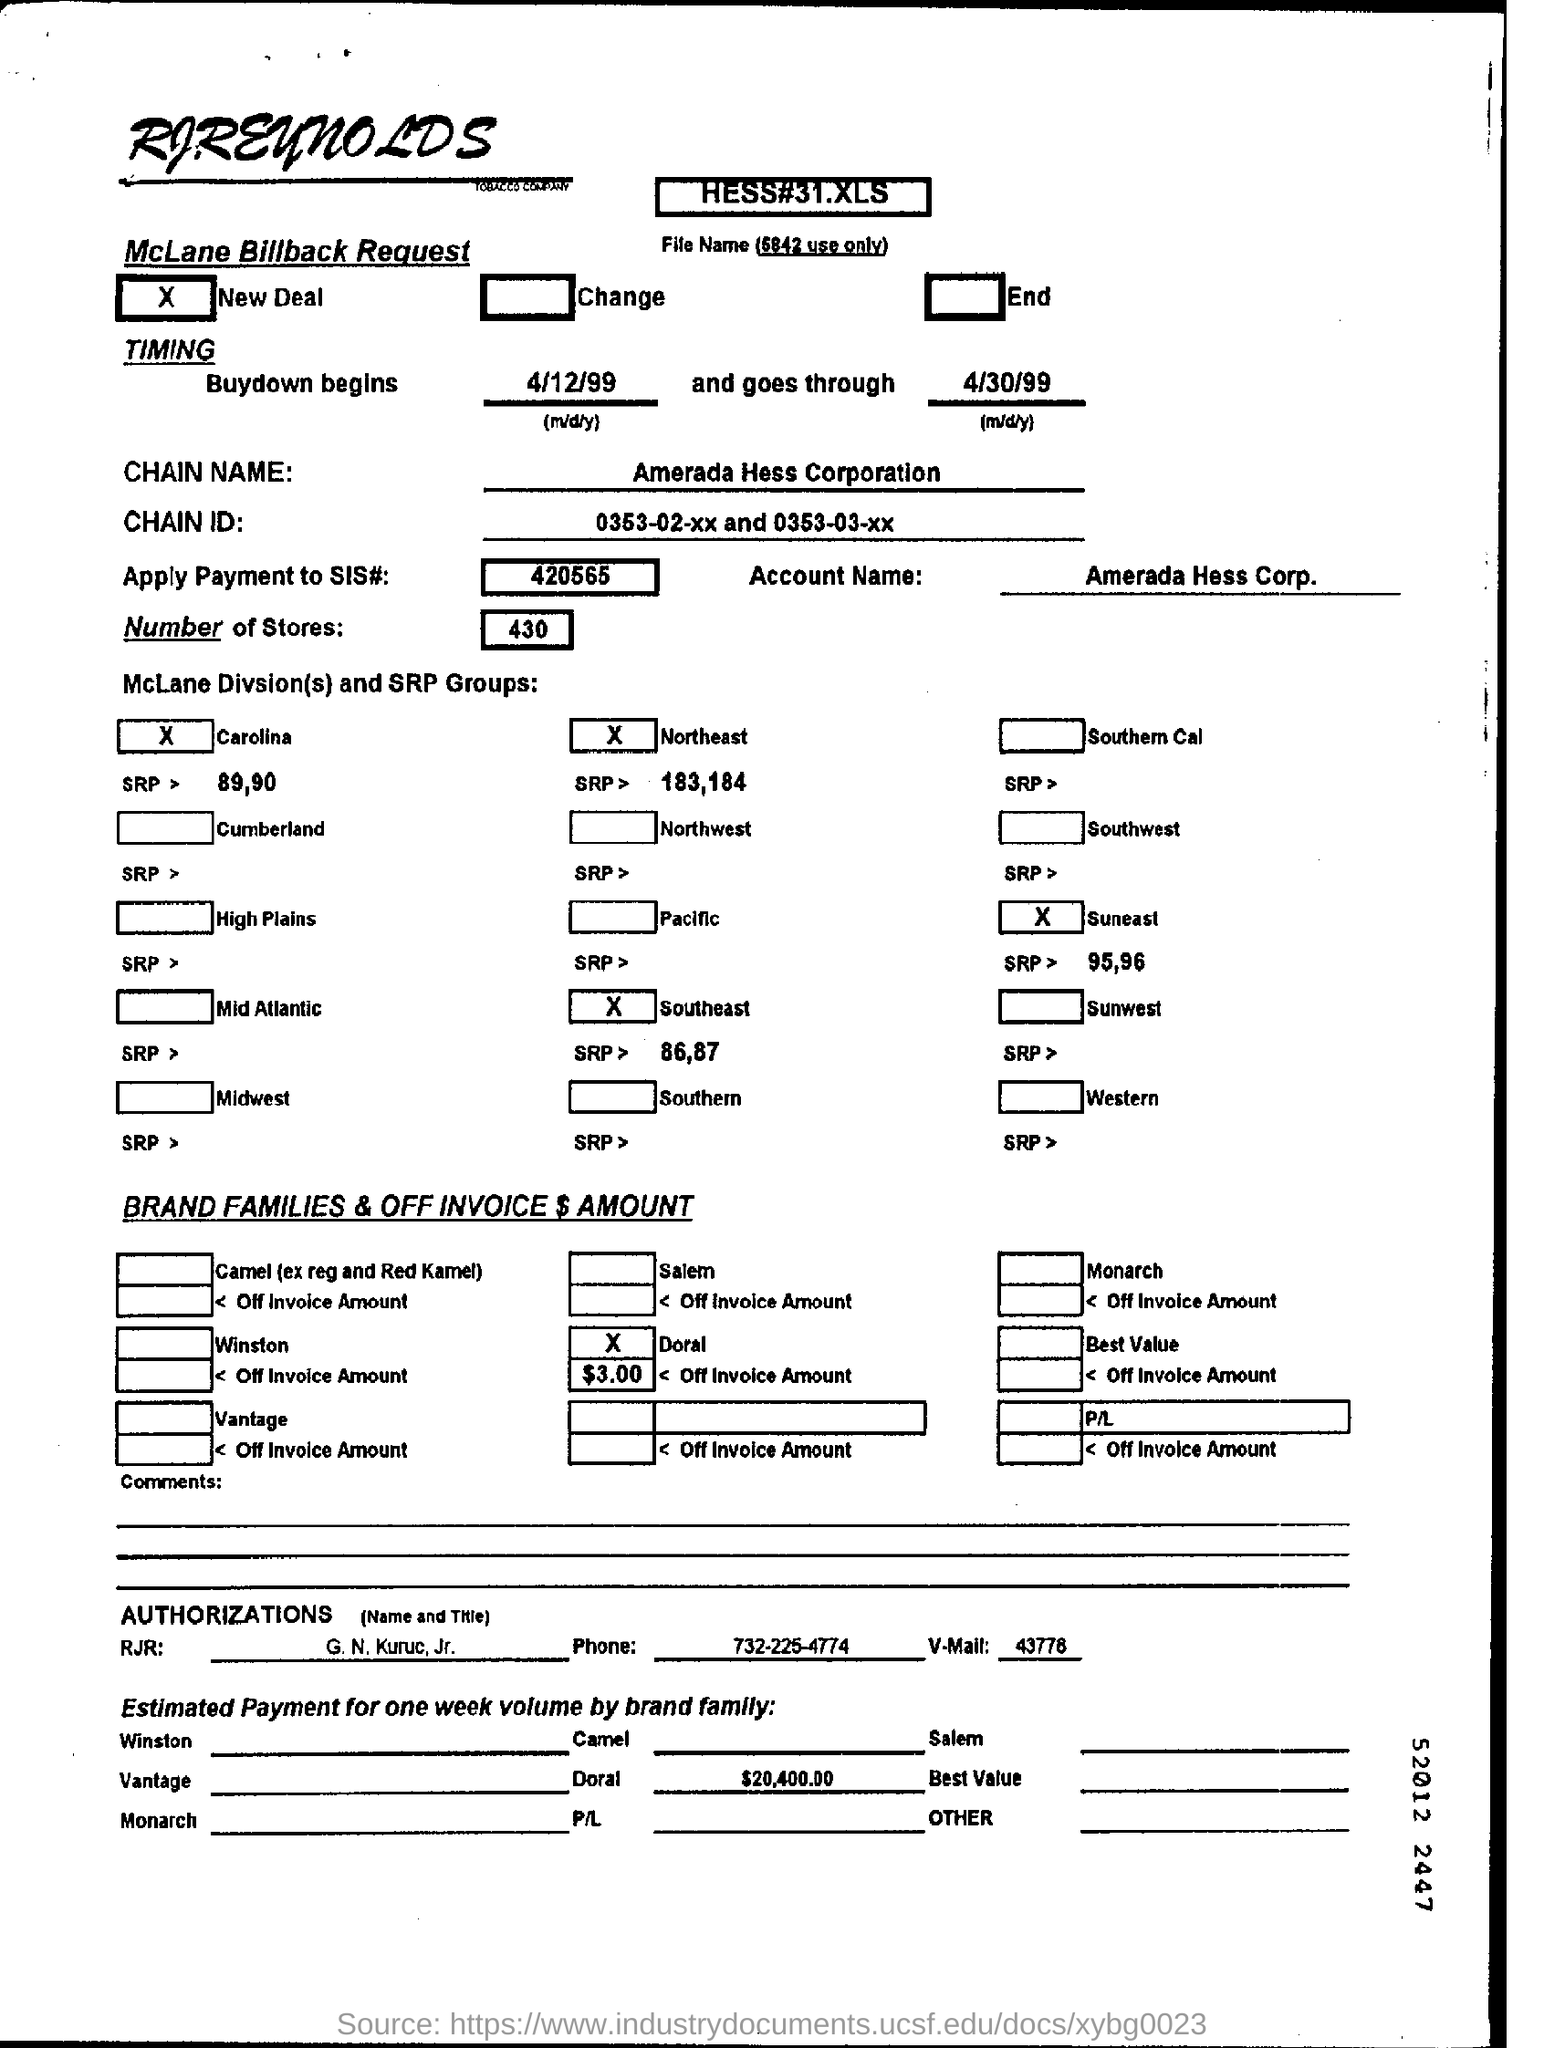What is the account name mentioned ?
Give a very brief answer. Amerada hess corp. What is the apply payment to sis# no. mentioned ?
Keep it short and to the point. 420565. What is the chain name mentioned ?
Keep it short and to the point. Amerada Hess Corporation. What are  the number of stores mentioned ?
Ensure brevity in your answer.  430. What is the phone no. mentioned ?
Provide a short and direct response. 732-225-4774. What is the estimated payment of doral mentioned ?
Your response must be concise. $ 20,400.00. 